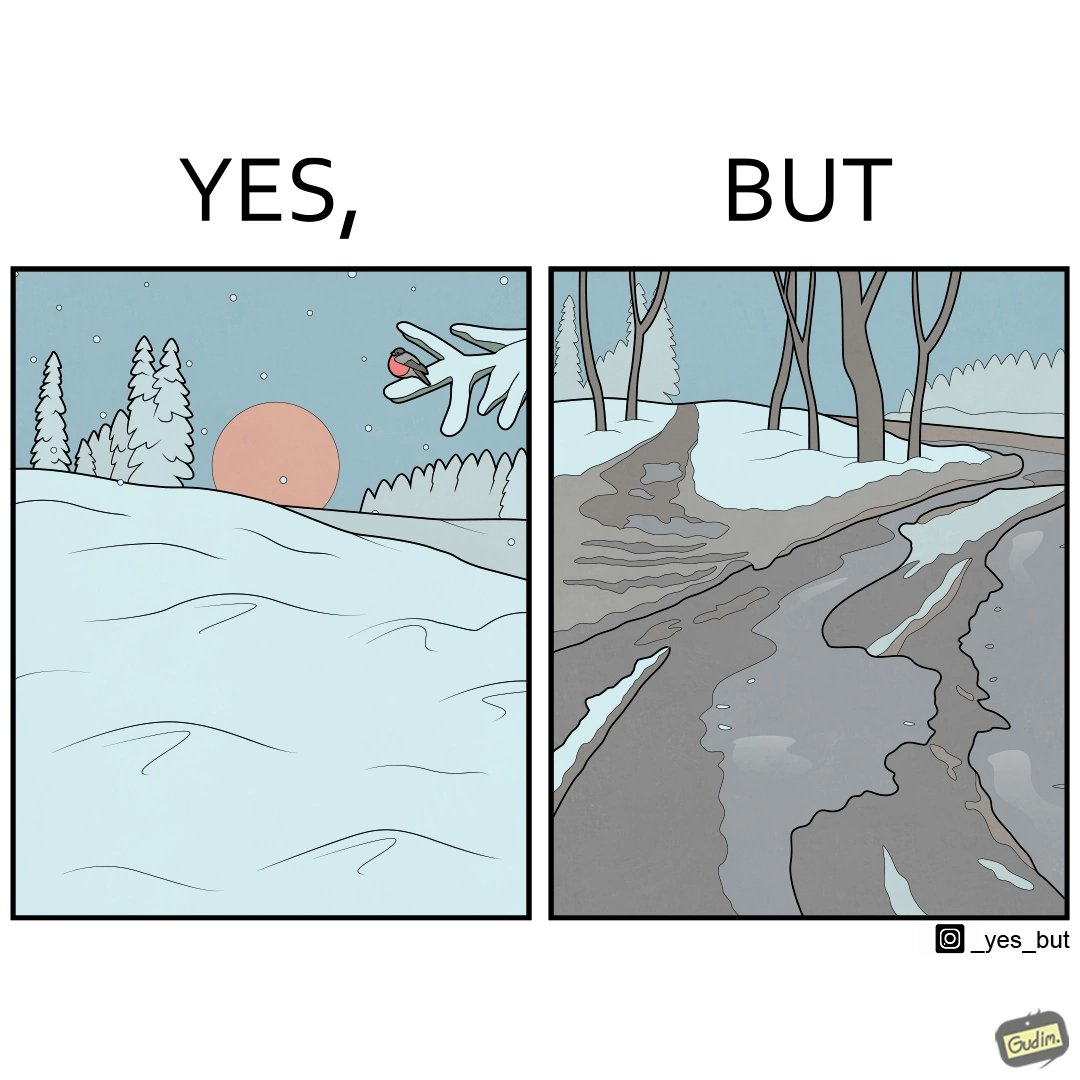Compare the left and right sides of this image. In the left part of the image: Trees and ground covered by snow due to snowfall, with a bird resting on a branch, and the Sun in the sky. In the right part of the image: Snow covered trees, and the ground partially covered in snow. 